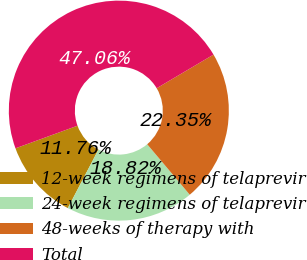Convert chart to OTSL. <chart><loc_0><loc_0><loc_500><loc_500><pie_chart><fcel>12-week regimens of telaprevir<fcel>24-week regimens of telaprevir<fcel>48-weeks of therapy with<fcel>Total<nl><fcel>11.76%<fcel>18.82%<fcel>22.35%<fcel>47.06%<nl></chart> 